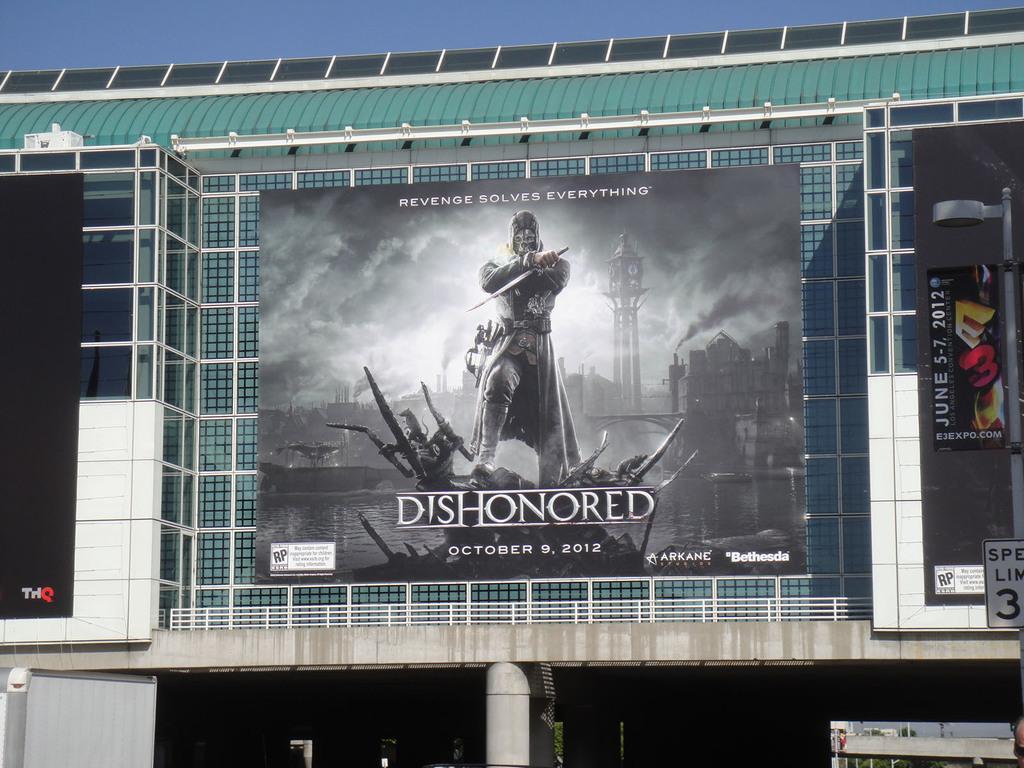Please provide a concise description of this image. In this picture we can see hoardings and glasses. In the background there is sky. 